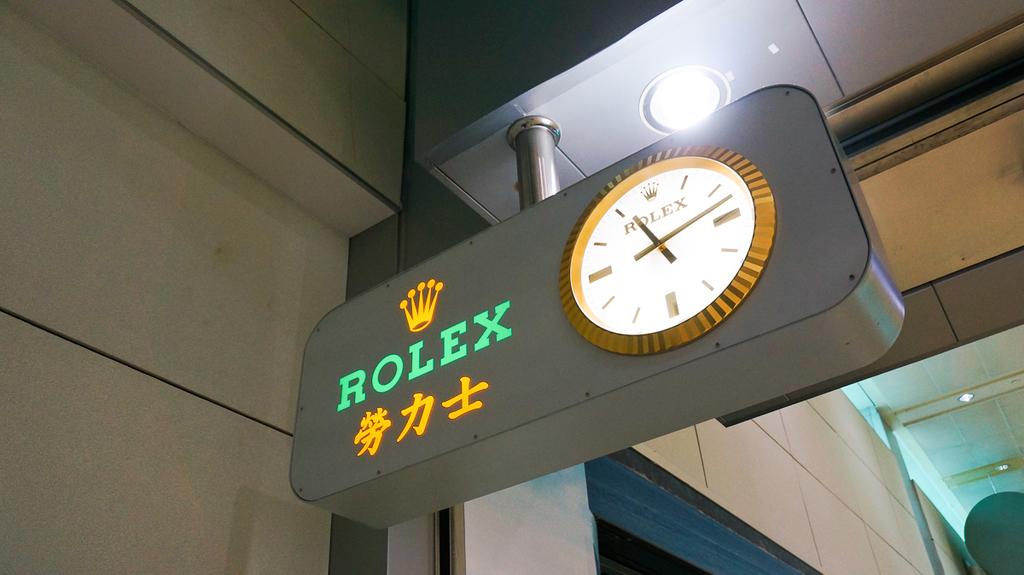What type of clock is that?
Ensure brevity in your answer.  Rolex. 